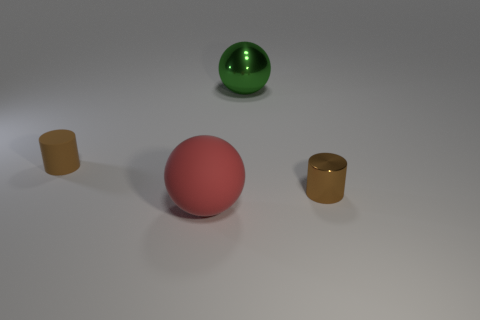How many metallic objects have the same color as the large rubber thing?
Ensure brevity in your answer.  0. Does the tiny rubber object have the same color as the tiny cylinder to the right of the large shiny thing?
Keep it short and to the point. Yes. Are there fewer big green balls than cylinders?
Make the answer very short. Yes. Are there more small brown cylinders that are right of the green ball than brown matte cylinders that are to the right of the red ball?
Give a very brief answer. Yes. Does the red sphere have the same material as the large green sphere?
Give a very brief answer. No. What number of tiny cylinders are to the right of the big object in front of the tiny brown rubber thing?
Offer a terse response. 1. There is a cylinder that is in front of the small brown rubber thing; is its color the same as the tiny matte thing?
Ensure brevity in your answer.  Yes. How many things are tiny purple cylinders or tiny brown objects to the left of the metallic sphere?
Keep it short and to the point. 1. There is a tiny thing that is in front of the rubber cylinder; does it have the same shape as the large thing that is behind the red thing?
Provide a succinct answer. No. Is there any other thing that is the same color as the rubber cylinder?
Offer a very short reply. Yes. 